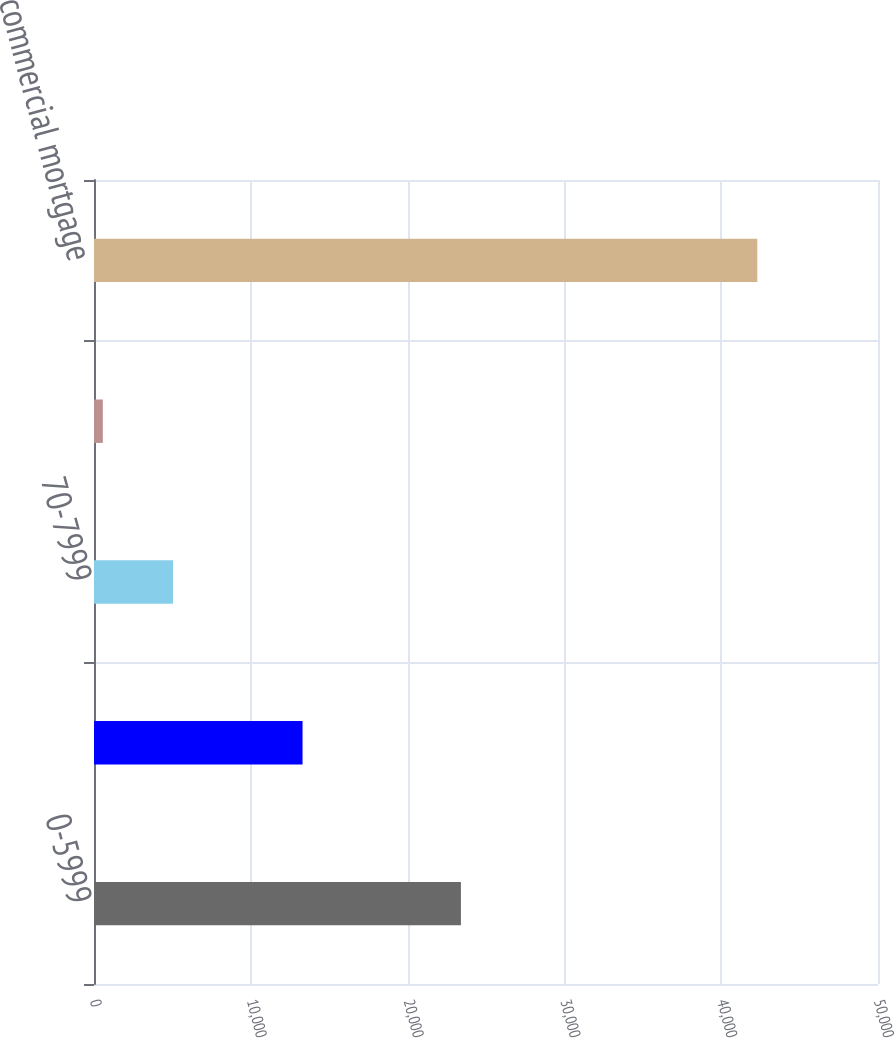<chart> <loc_0><loc_0><loc_500><loc_500><bar_chart><fcel>0-5999<fcel>60-6999<fcel>70-7999<fcel>Greater than 80<fcel>Total commercial mortgage<nl><fcel>23401<fcel>13300<fcel>5039<fcel>563<fcel>42303<nl></chart> 